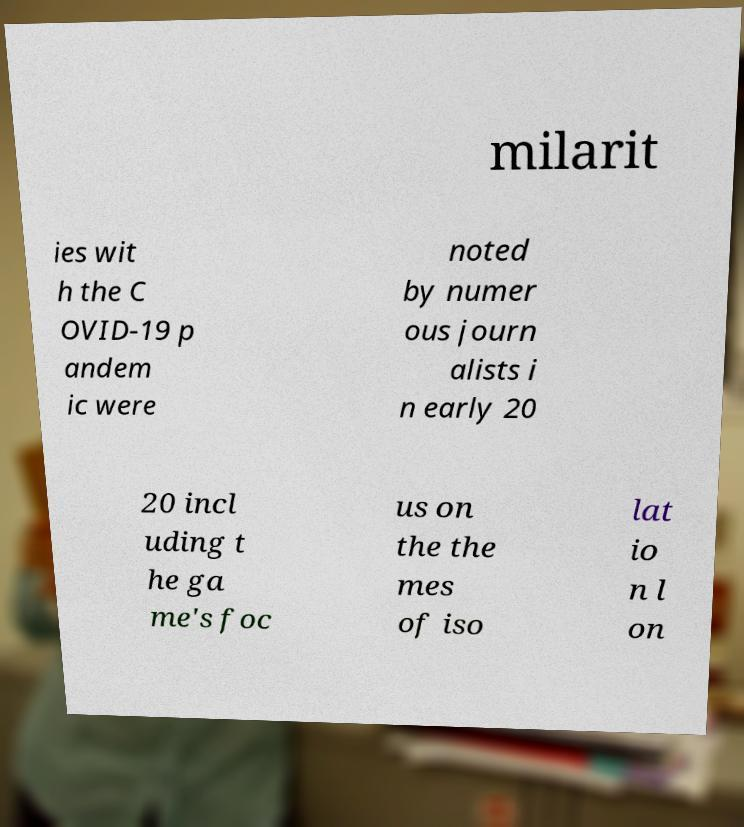Can you read and provide the text displayed in the image?This photo seems to have some interesting text. Can you extract and type it out for me? milarit ies wit h the C OVID-19 p andem ic were noted by numer ous journ alists i n early 20 20 incl uding t he ga me's foc us on the the mes of iso lat io n l on 